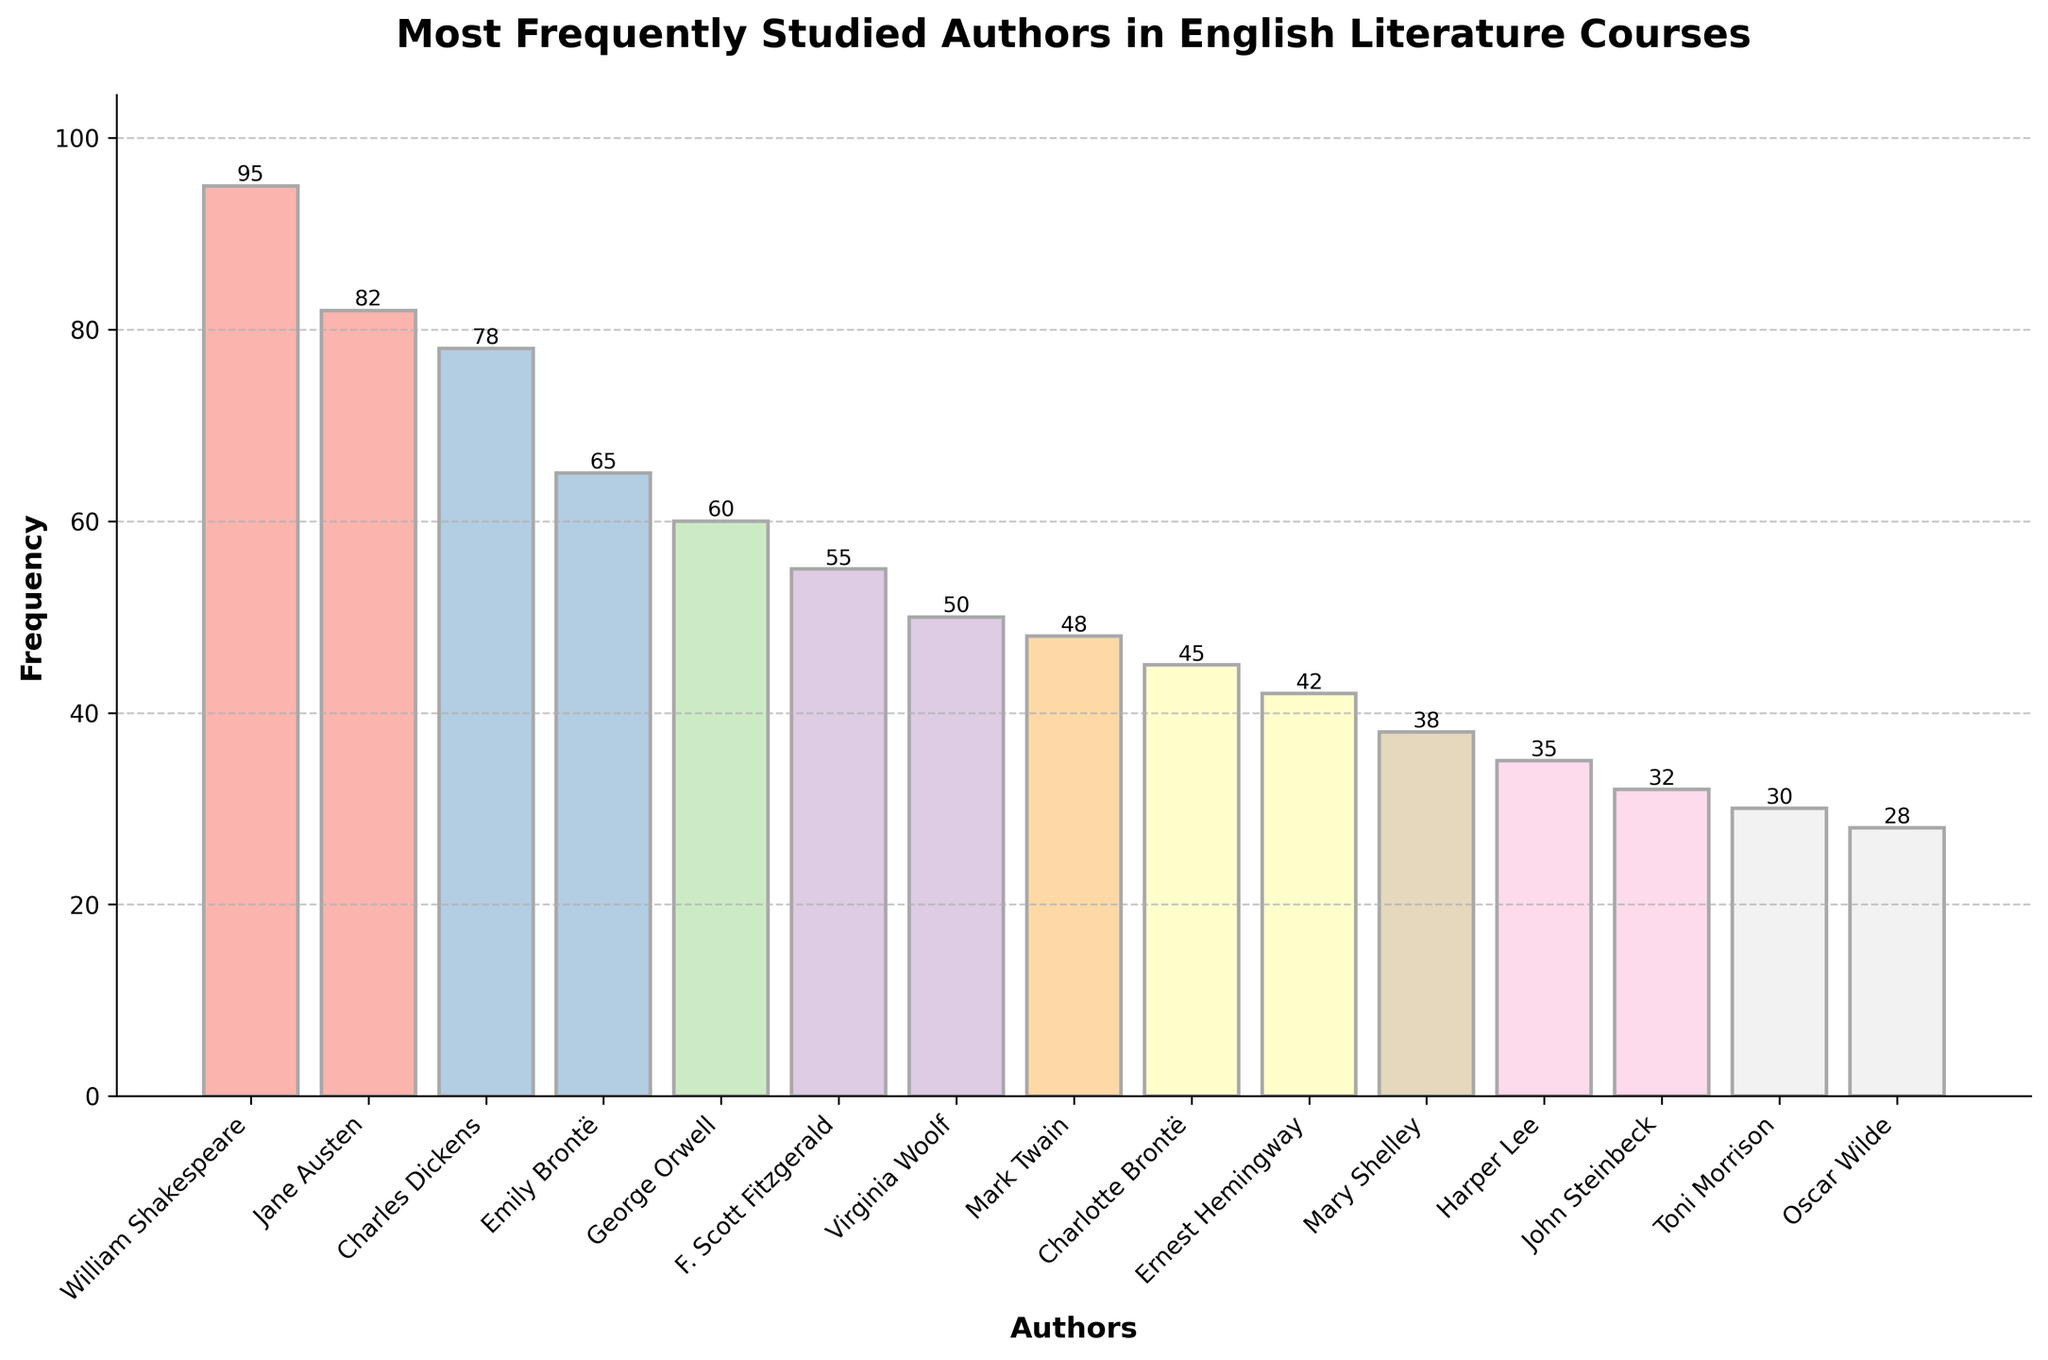Who is the most frequently studied author in English literature courses? Look at the bar with the highest frequency. William Shakespeare is the author with a frequency of 95.
Answer: William Shakespeare How many authors have a frequency of study of 50 or higher? Count the bars with their frequencies indicated as 50 or more. There are 7 such authors: William Shakespeare, Jane Austen, Charles Dickens, Emily Brontë, George Orwell, F. Scott Fitzgerald, and Virginia Woolf.
Answer: 7 Which author is studied more frequently: Emily Brontë or Charlotte Brontë? Compare the heights of the bars for Emily Brontë and Charlotte Brontë. Emily Brontë has a frequency of 65, which is higher than Charlotte Brontë's 45.
Answer: Emily Brontë What is the difference in frequency between the most and least studied authors? Subtract the frequency of the least studied author (Oscar Wilde, 28) from the most studied author (William Shakespeare, 95). 95 - 28 = 67.
Answer: 67 Which authors have frequencies that fall between 40 and 60? Identify the bars with heights corresponding to frequencies between 40 and 60. They are Ernest Hemingway (42), Charlotte Brontë (45), Mark Twain (48), and Virginia Woolf (50).
Answer: Ernest Hemingway, Charlotte Brontë, Mark Twain, Virginia Woolf What is the combined frequency of Jane Austen and Charles Dickens? Add the frequencies of Jane Austen (82) and Charles Dickens (78). 82 + 78 = 160.
Answer: 160 Which two authors have the smallest difference in their frequencies of study? Check the frequency values and find the smallest difference. The smallest difference is 2 between Mark Twain (48) and Charlotte Brontë (45).
Answer: Mark Twain and Charlotte Brontë How much more frequently is George Orwell studied compared to Mary Shelley? Subtract Mary Shelley's frequency (38) from George Orwell's (60). 60 - 38 = 22.
Answer: 22 What is the average frequency of the top 5 most frequently studied authors? Add the frequencies of the top 5 authors (William Shakespeare: 95, Jane Austen: 82, Charles Dickens: 78, Emily Brontë: 65, George Orwell: 60) and divide by 5. (95 + 82 + 78 + 65 + 60) / 5 = 76.
Answer: 76 How do the colors of the bars vary throughout the bar chart? The bars are colored using a gradient from a pastel color scale, which means the colors vary smoothly from one shade to another, providing a visually pleasing transition.
Answer: They vary smoothly in pastel shades 